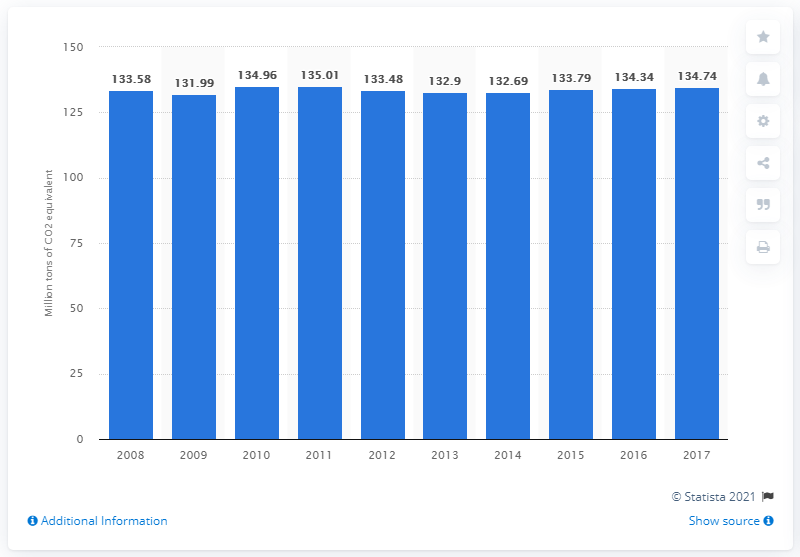Indicate a few pertinent items in this graphic. In 2017, fuel combustion in France resulted in the production of 134.74 metric tons of CO2 equivalent. 